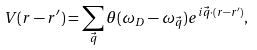Convert formula to latex. <formula><loc_0><loc_0><loc_500><loc_500>V ( { r } - { r } ^ { \prime } ) = \sum _ { \vec { q } } \theta ( \omega _ { D } - \omega _ { \vec { q } } ) e ^ { i { \vec { q } } \cdot ( { r } - { r } ^ { \prime } ) } ,</formula> 